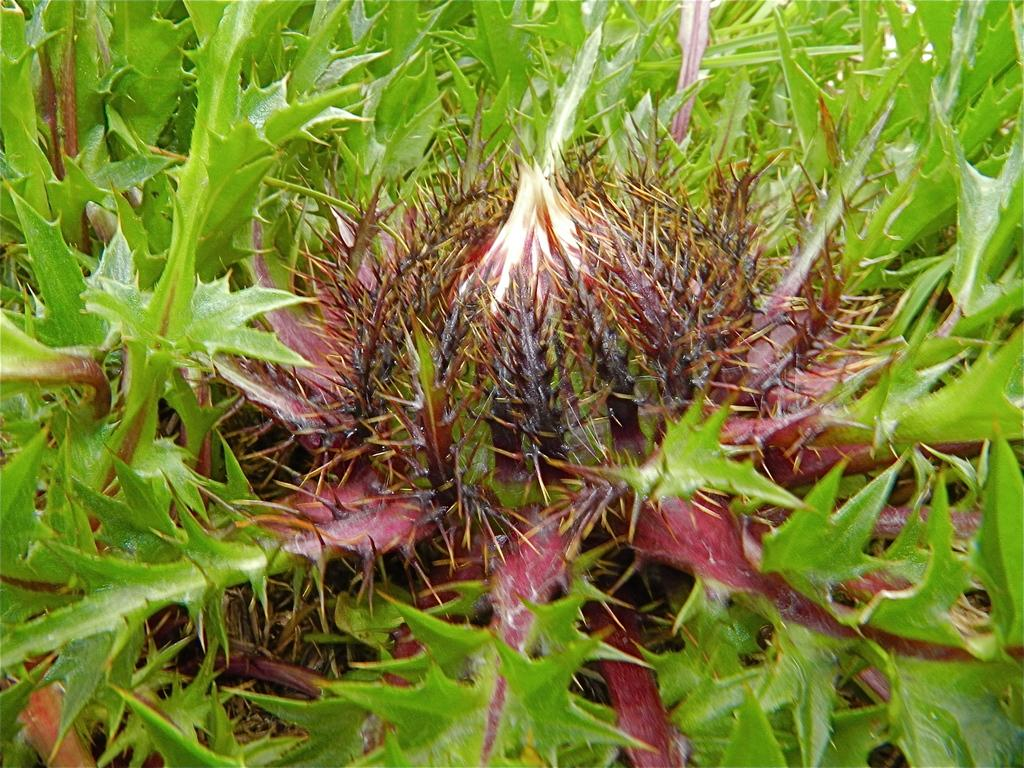What type of living organisms can be seen in the image? Plants can be seen in the image. What specific characteristic do these plants have? The plants have spikes. What type of pet can be seen playing with a joke in the image? There is no pet or joke present in the image; it features plants with spikes. 